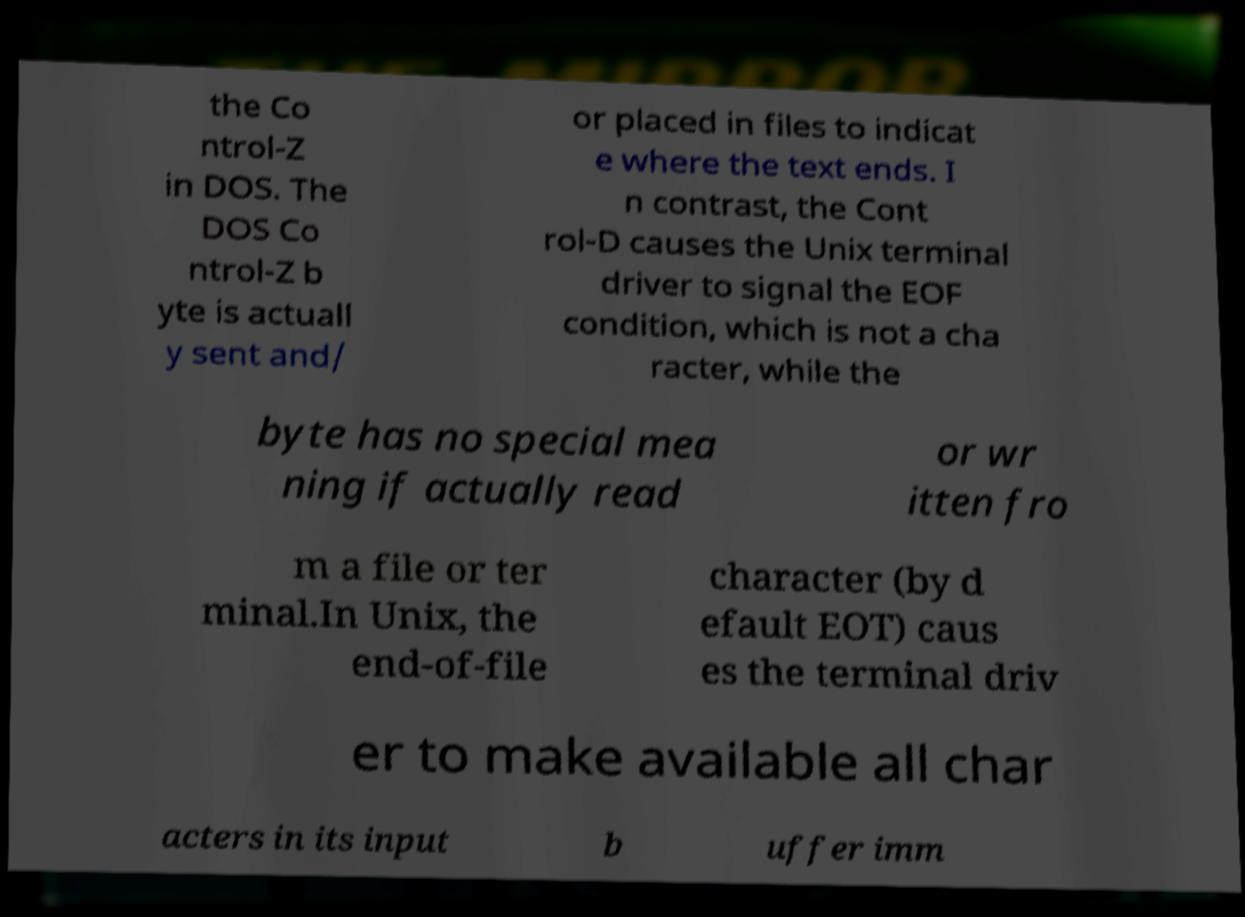Could you extract and type out the text from this image? the Co ntrol-Z in DOS. The DOS Co ntrol-Z b yte is actuall y sent and/ or placed in files to indicat e where the text ends. I n contrast, the Cont rol-D causes the Unix terminal driver to signal the EOF condition, which is not a cha racter, while the byte has no special mea ning if actually read or wr itten fro m a file or ter minal.In Unix, the end-of-file character (by d efault EOT) caus es the terminal driv er to make available all char acters in its input b uffer imm 